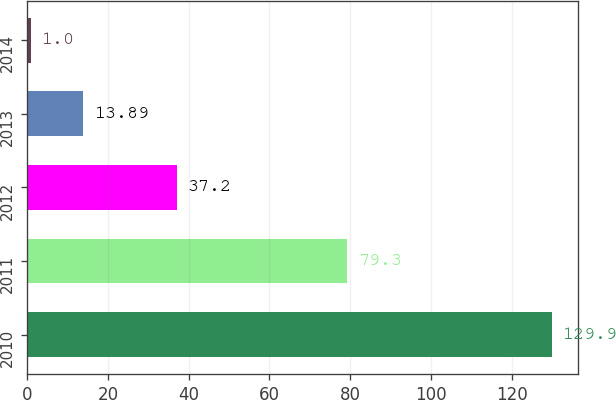Convert chart to OTSL. <chart><loc_0><loc_0><loc_500><loc_500><bar_chart><fcel>2010<fcel>2011<fcel>2012<fcel>2013<fcel>2014<nl><fcel>129.9<fcel>79.3<fcel>37.2<fcel>13.89<fcel>1<nl></chart> 